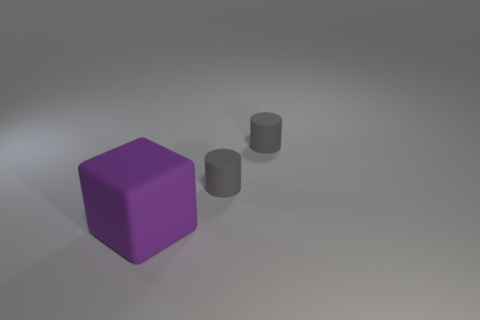Add 2 gray rubber objects. How many objects exist? 5 Subtract 0 purple cylinders. How many objects are left? 3 Subtract all cylinders. How many objects are left? 1 Subtract 1 blocks. How many blocks are left? 0 Subtract all cyan cylinders. Subtract all purple blocks. How many cylinders are left? 2 Subtract all brown blocks. How many brown cylinders are left? 0 Subtract all tiny blue matte cubes. Subtract all tiny matte cylinders. How many objects are left? 1 Add 3 rubber cylinders. How many rubber cylinders are left? 5 Add 1 gray matte things. How many gray matte things exist? 3 